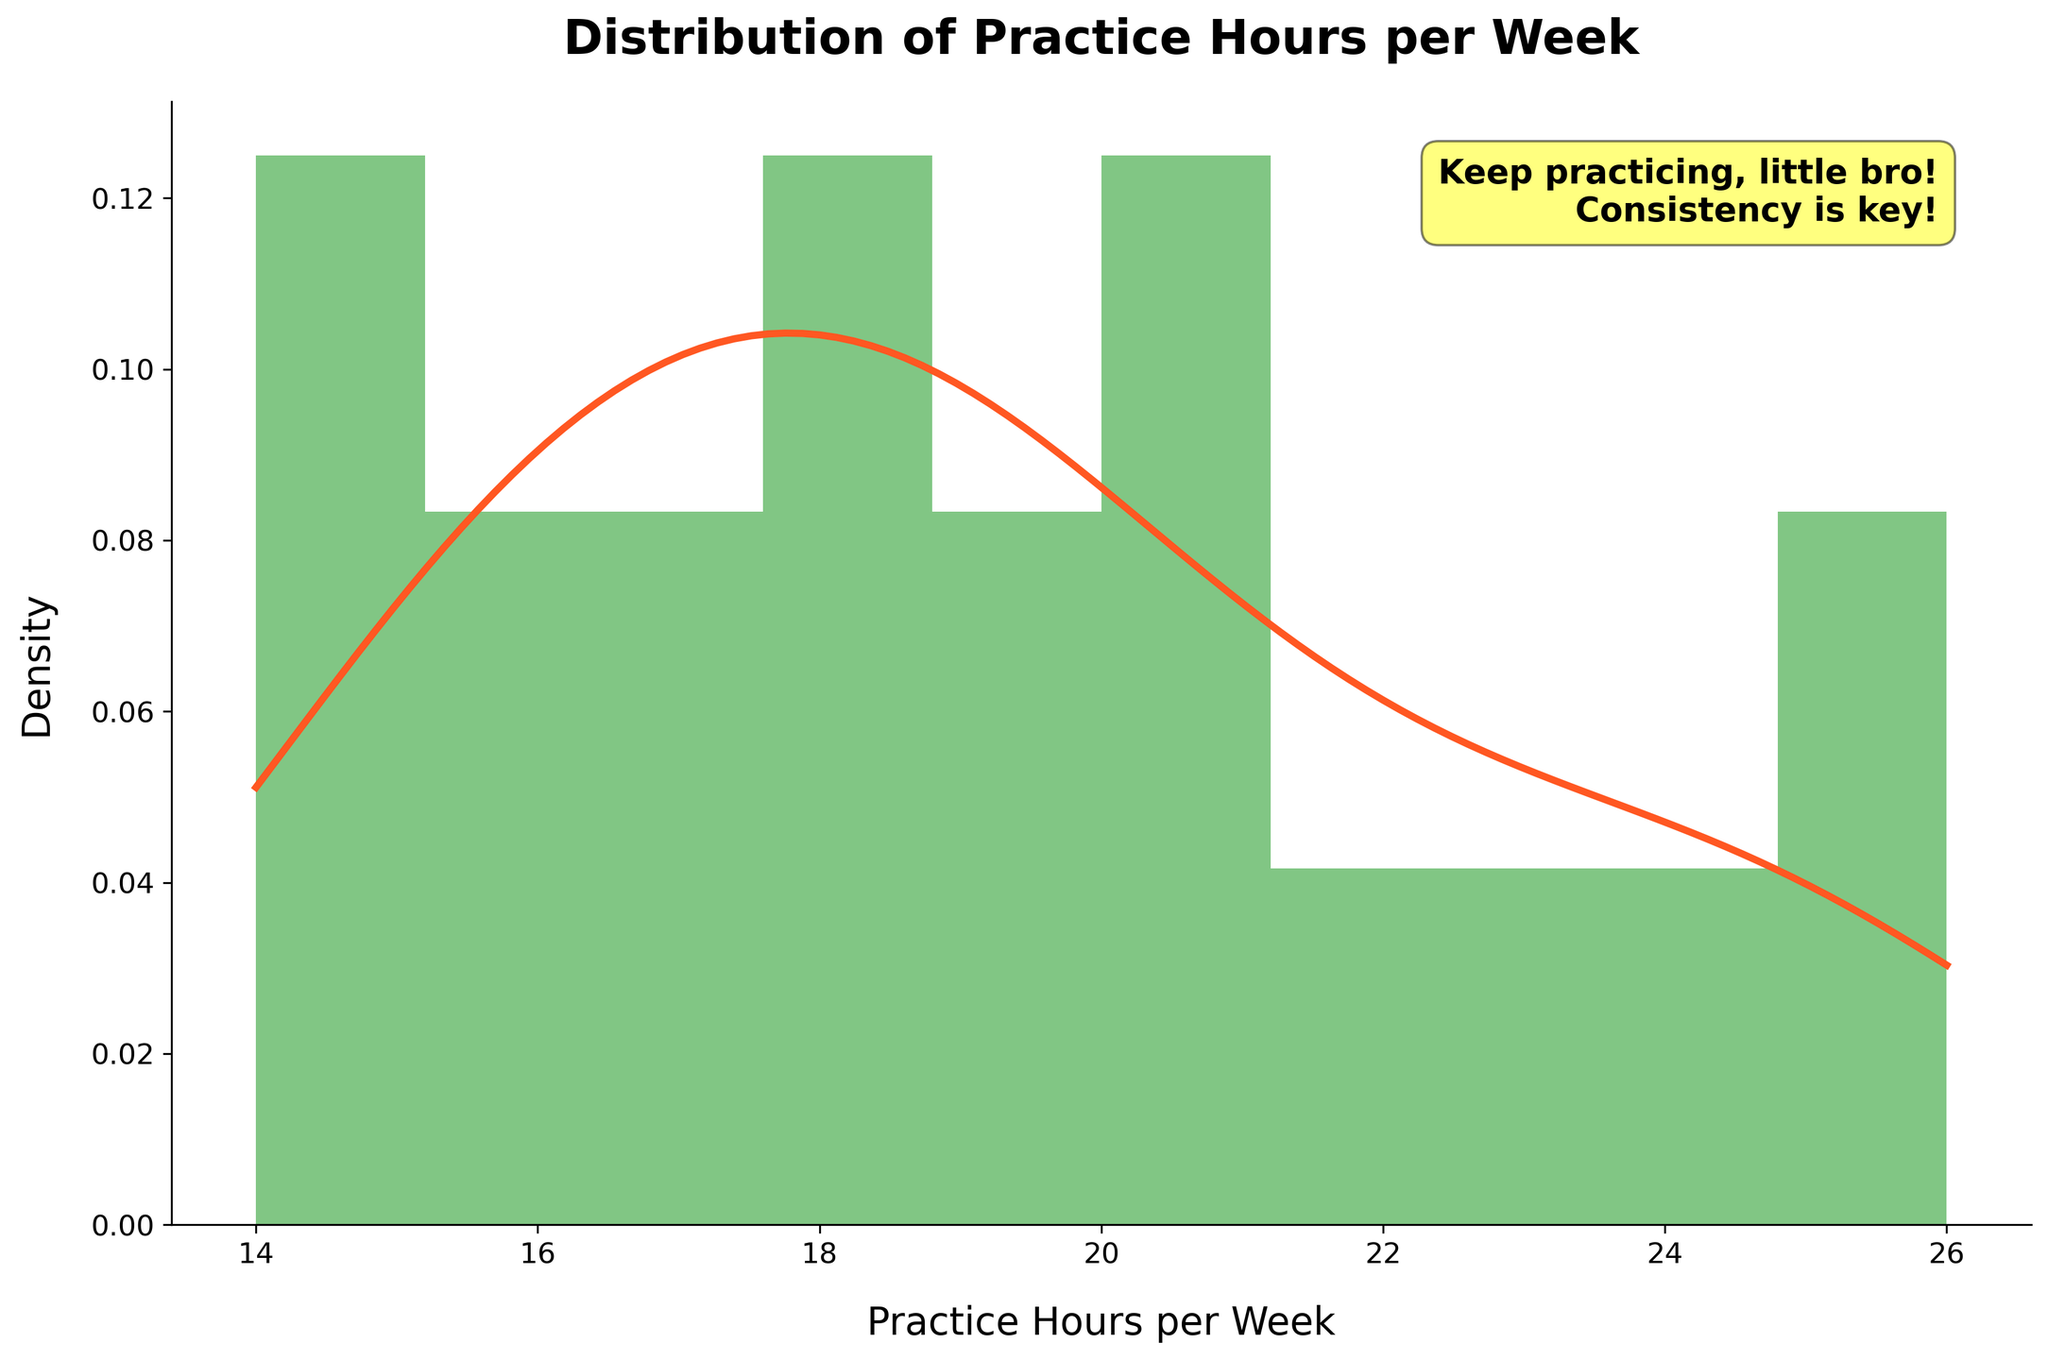what's the title of the figure? The title is usually placed at the top center of the figure. Looking there reveals that it is about 'Distribution of Practice Hours per Week'.
Answer: Distribution of Practice Hours per Week How many data points (histogram bins) are shown in the figure? The histogram uses bins to count data points. By observing the number of bars, we count 10.
Answer: 10 What is the practice hours range displayed on the x-axis? Checking both ends of the x-axis reveals the minimum and maximum values displayed, which represent the range.
Answer: 14 to 26 Does the KDE curve have a single peak (unimodal) or multiple peaks (multimodal)? We can look at the density curve to determine the number of distinct peaks. Only one peak is prominent.
Answer: Unimodal At around how many practice hours is the highest density observed on the KDE curve? We identify the highest point on the KDE curve and read its corresponding x-value. The peak appears around 18 practice hours per week.
Answer: 18 hours Which bin contains the most practice hours data points? Identify the tallest bar in the histogram. The bin around 18 practice hours appears to be the tallest one.
Answer: 18 hours What are the minimum and maximum practice hours seen among successful performers? Look for the smallest and largest x-values where histogram bars are present. The minimum is 14, and the maximum is 26 hours.
Answer: 14 and 26 hours True or False: Most successful performers practice between 16 and 20 hours per week. By examining the histogram and KDE, most data points and the peak density are around this range.
Answer: True Compare the density of practice hours at 17 and 25 hours per week. Which is higher? Observe the heights of the KDE curve at these points. The KDE curve is higher at 17 hours compared to 25 hours.
Answer: 17 hours What's the approximate height of the highest peak of the KDE curve? We need to approximate the y-value at the highest point of the KDE density curve, which seems to be slightly below 0.1.
Answer: ~0.09 